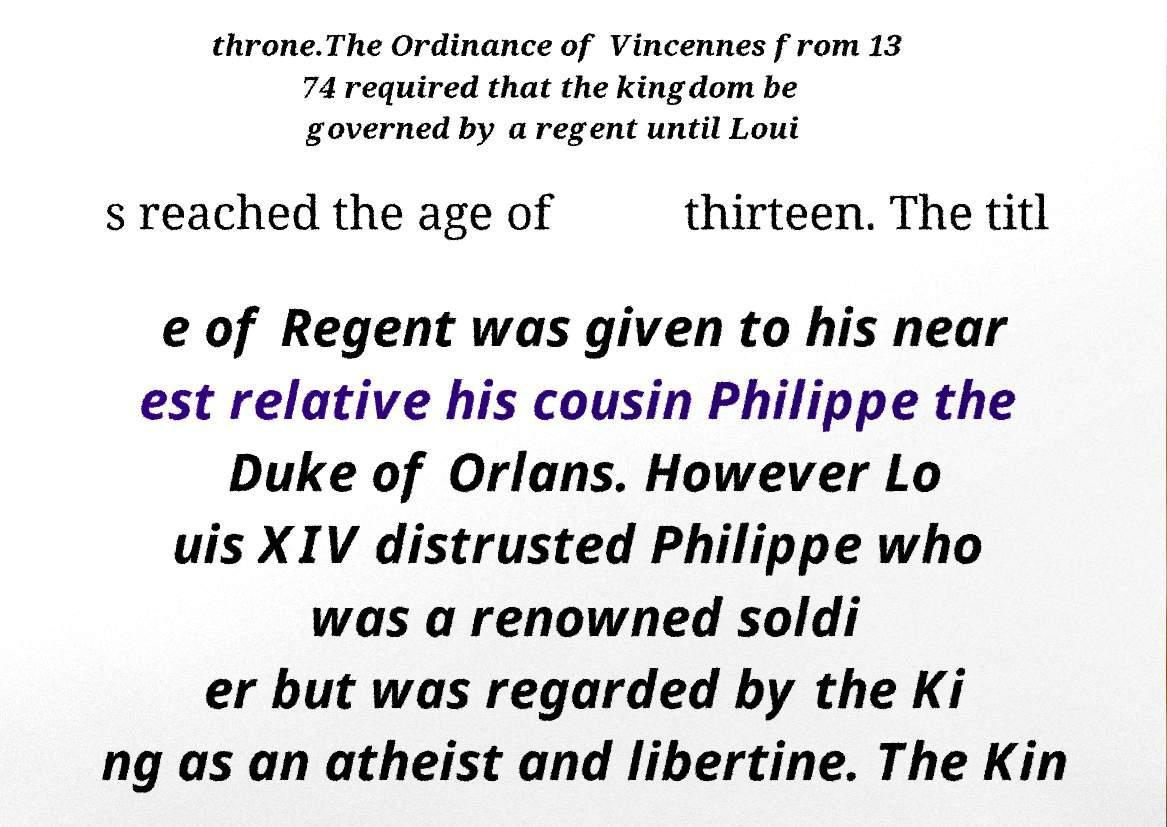Please identify and transcribe the text found in this image. throne.The Ordinance of Vincennes from 13 74 required that the kingdom be governed by a regent until Loui s reached the age of thirteen. The titl e of Regent was given to his near est relative his cousin Philippe the Duke of Orlans. However Lo uis XIV distrusted Philippe who was a renowned soldi er but was regarded by the Ki ng as an atheist and libertine. The Kin 